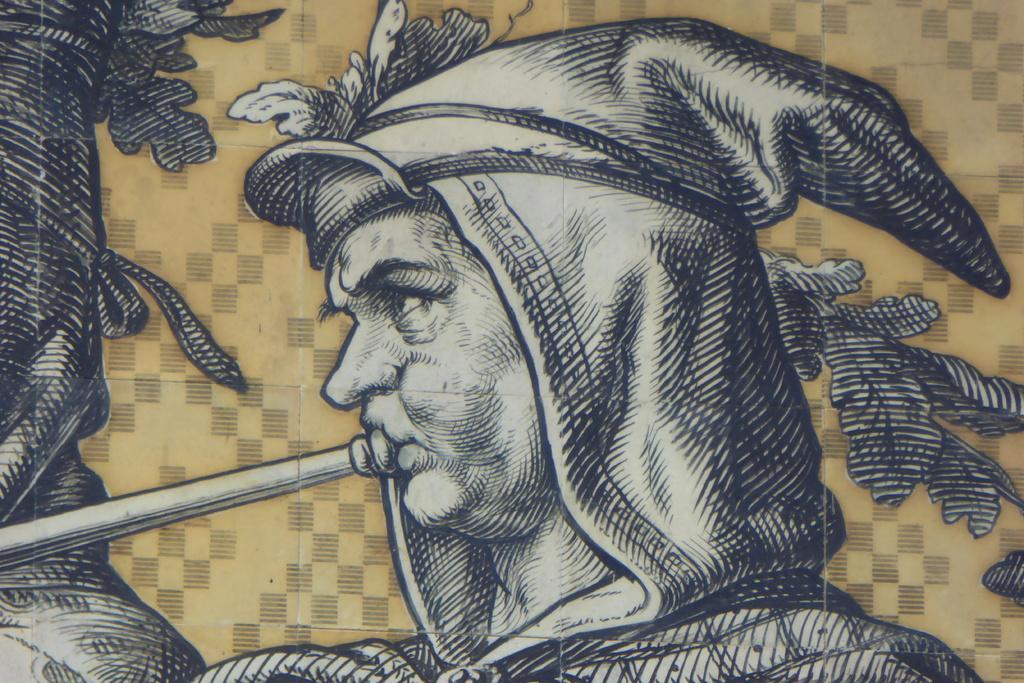In one or two sentences, can you explain what this image depicts? In this picture we can see a person wearing a cap attached to his dress. This person is playing a musical instrument. We can see some art on a creamy background. 